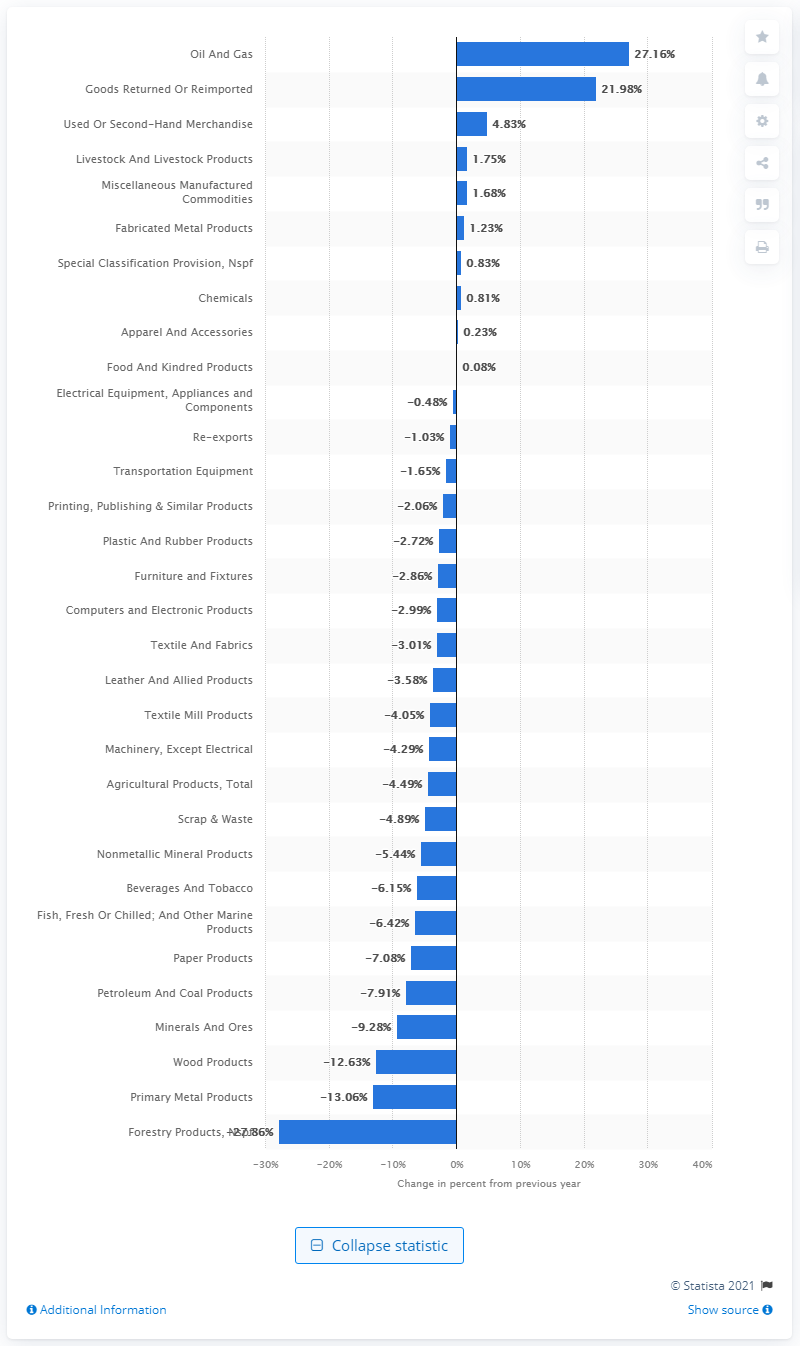List a handful of essential elements in this visual. In 2019, the United States export of oil and gas increased by 27.16% compared to the previous year. 